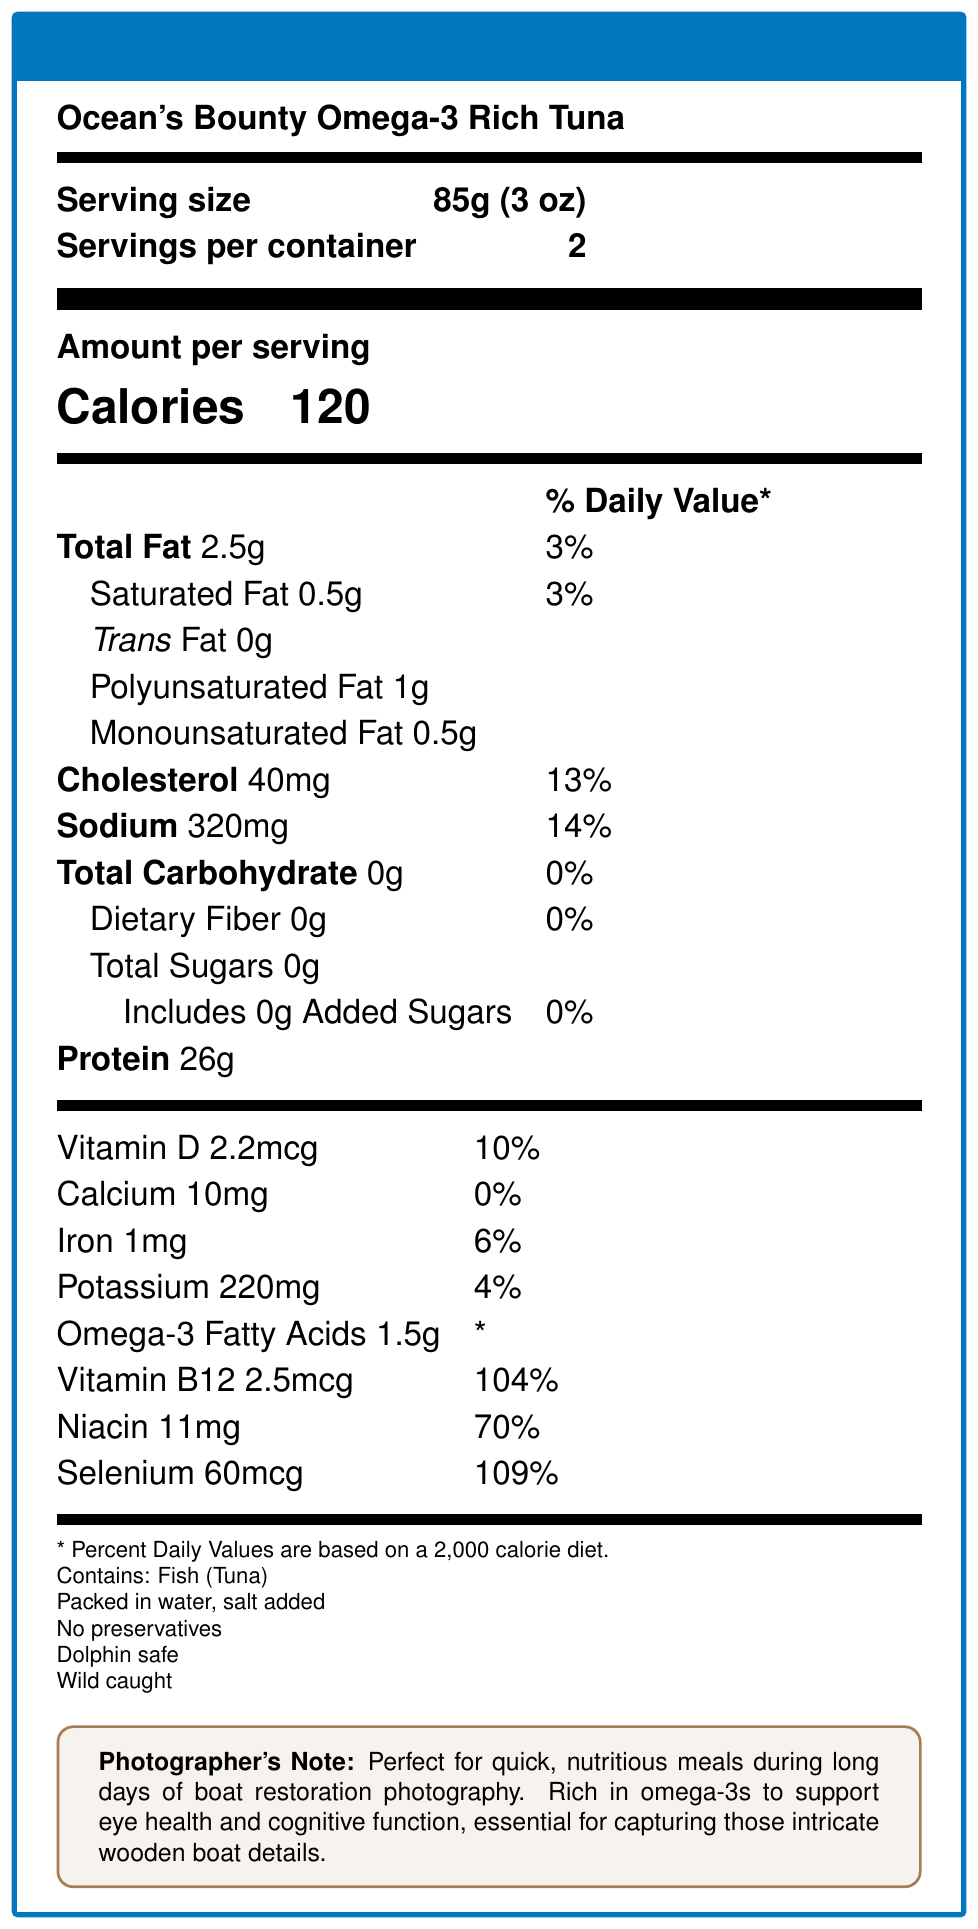what is the serving size? The serving size is explicitly stated in the document as "85g (3 oz)".
Answer: 85g (3 oz) how many servings are in a container? The document specifies that there are 2 servings per container.
Answer: 2 how many calories does one serving contain? The document states that each serving contains 120 calories.
Answer: 120 what is the amount of protein per serving? The document lists 26g of protein per serving.
Answer: 26g what are the main vitamins included in the product? The vitamins section lists Vitamin D, Vitamin B12, Niacin, and Selenium among the nutritional information.
Answer: Vitamin D, Vitamin B12, Niacin, Selenium what percent daily value of cholesterol does one serving contain? A. 10% B. 13% C. 14% D. 3% The document states that one serving contains 13% of the daily value for cholesterol.
Answer: B which of the following is not listed as part of the additional info? A. Contains: Fish (Tuna) B. Packed in water C. No added sugars D. Dolphin safe The options listed in the additional information are "Contains: Fish (Tuna)", "Packed in water", "No preservatives", "Dolphin safe", and "Wild caught", but "No added sugars" is not included.
Answer: C does one serving contain any added sugars? The document explicitly states that there are 0g of added sugars per serving.
Answer: No is this product dolphin safe? The document includes "Dolphin safe" in the additional information section.
Answer: Yes explain the main idea of the document. The explanation describes the type of product (Ocean's Bounty Omega-3 Rich Tuna), the nutritional content included, and additional details such as being packed in water, dolphin safe, and wild caught. It also references a specific note for photographers, which underscores the nutritional benefits of the product.
Answer: The document provides detailed nutritional information for a product called Ocean's Bounty Omega-3 Rich Tuna. It includes serving size, calories, macronutrients, vitamins, and minerals. Additionally, it mentions that the product is packed in water with added salt, contains no preservatives, is dolphin safe, and wild caught. A note for photographers highlights its suitability as a nutritious option during long days of boat restoration photography due to its omega-3 content and other essential nutrients. how much monounsaturated fat does one serving contain? The document lists 0.5g of monounsaturated fat per serving.
Answer: 0.5g what minerals are included in the nutritional information? The mineral information listed in the document includes Calcium, Iron, Potassium, and Selenium.
Answer: Calcium, Iron, Potassium, Selenium how much sodium does one serving contain, and what is its daily value percentage? The document specifies that one serving contains 320mg of sodium, which is 14% of the daily value.
Answer: 320mg, 14% does the product contain preservatives? The document specifies that the product contains no preservatives.
Answer: No how much dietary fiber is in one serving? The document lists 0g of dietary fiber per serving.
Answer: 0g is this product suitable for vegetarians? The document states that the product contains fish (tuna), but it does not provide information about any other ingredients or potential suitability for vegetarians.
Answer: Cannot be determined what is the amount of omega-3 fatty acids in one serving? The document lists 1.5g of omega-3 fatty acids per serving.
Answer: 1.5g 